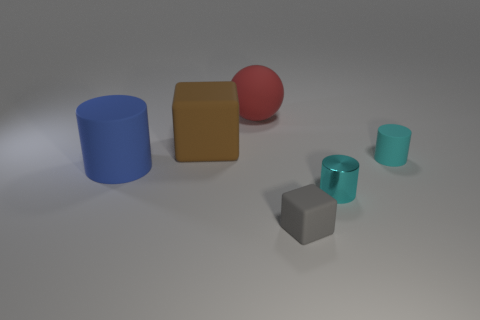Add 2 brown metal blocks. How many objects exist? 8 Subtract all spheres. How many objects are left? 5 Subtract all big brown matte spheres. Subtract all gray rubber cubes. How many objects are left? 5 Add 4 gray objects. How many gray objects are left? 5 Add 5 large matte things. How many large matte things exist? 8 Subtract 0 green blocks. How many objects are left? 6 